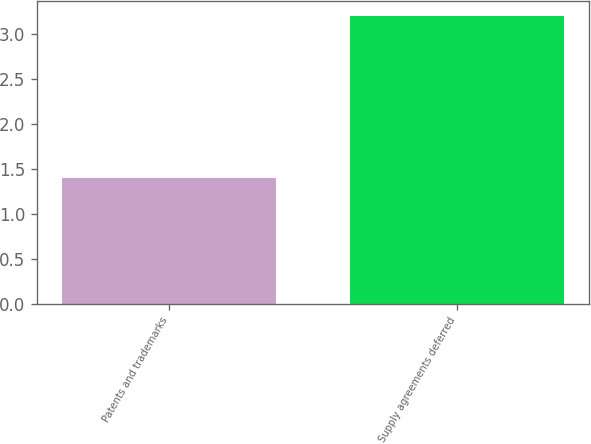Convert chart. <chart><loc_0><loc_0><loc_500><loc_500><bar_chart><fcel>Patents and trademarks<fcel>Supply agreements deferred<nl><fcel>1.4<fcel>3.2<nl></chart> 